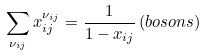Convert formula to latex. <formula><loc_0><loc_0><loc_500><loc_500>\sum _ { \nu _ { i j } } x _ { i j } ^ { \nu _ { i j } } = \frac { 1 } { 1 - x _ { i j } } \, ( b o s o n s )</formula> 